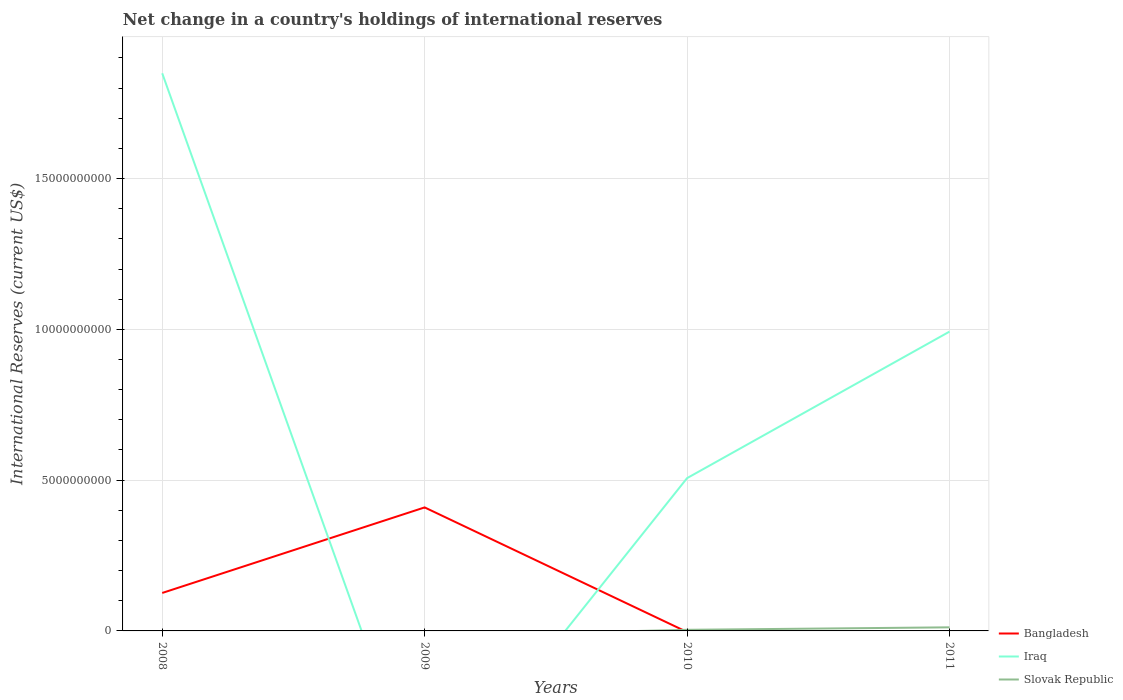How many different coloured lines are there?
Your answer should be very brief. 3. Does the line corresponding to Bangladesh intersect with the line corresponding to Iraq?
Provide a succinct answer. Yes. Is the number of lines equal to the number of legend labels?
Give a very brief answer. No. What is the total international reserves in Bangladesh in the graph?
Ensure brevity in your answer.  -2.84e+09. What is the difference between the highest and the second highest international reserves in Iraq?
Keep it short and to the point. 1.85e+1. Does the graph contain any zero values?
Your answer should be compact. Yes. Does the graph contain grids?
Offer a very short reply. Yes. What is the title of the graph?
Your response must be concise. Net change in a country's holdings of international reserves. Does "Arab World" appear as one of the legend labels in the graph?
Provide a succinct answer. No. What is the label or title of the X-axis?
Provide a succinct answer. Years. What is the label or title of the Y-axis?
Your answer should be compact. International Reserves (current US$). What is the International Reserves (current US$) in Bangladesh in 2008?
Provide a succinct answer. 1.26e+09. What is the International Reserves (current US$) in Iraq in 2008?
Provide a succinct answer. 1.85e+1. What is the International Reserves (current US$) of Slovak Republic in 2008?
Provide a short and direct response. 0. What is the International Reserves (current US$) in Bangladesh in 2009?
Keep it short and to the point. 4.10e+09. What is the International Reserves (current US$) of Iraq in 2009?
Provide a short and direct response. 0. What is the International Reserves (current US$) in Slovak Republic in 2009?
Your answer should be compact. 0. What is the International Reserves (current US$) of Iraq in 2010?
Keep it short and to the point. 5.07e+09. What is the International Reserves (current US$) in Slovak Republic in 2010?
Offer a very short reply. 3.67e+07. What is the International Reserves (current US$) of Iraq in 2011?
Keep it short and to the point. 9.92e+09. What is the International Reserves (current US$) in Slovak Republic in 2011?
Keep it short and to the point. 1.19e+08. Across all years, what is the maximum International Reserves (current US$) in Bangladesh?
Your answer should be compact. 4.10e+09. Across all years, what is the maximum International Reserves (current US$) of Iraq?
Ensure brevity in your answer.  1.85e+1. Across all years, what is the maximum International Reserves (current US$) of Slovak Republic?
Your response must be concise. 1.19e+08. Across all years, what is the minimum International Reserves (current US$) of Bangladesh?
Keep it short and to the point. 0. Across all years, what is the minimum International Reserves (current US$) of Iraq?
Keep it short and to the point. 0. What is the total International Reserves (current US$) in Bangladesh in the graph?
Offer a terse response. 5.35e+09. What is the total International Reserves (current US$) of Iraq in the graph?
Your answer should be compact. 3.35e+1. What is the total International Reserves (current US$) of Slovak Republic in the graph?
Your answer should be very brief. 1.56e+08. What is the difference between the International Reserves (current US$) of Bangladesh in 2008 and that in 2009?
Your answer should be compact. -2.84e+09. What is the difference between the International Reserves (current US$) in Iraq in 2008 and that in 2010?
Offer a very short reply. 1.34e+1. What is the difference between the International Reserves (current US$) in Iraq in 2008 and that in 2011?
Ensure brevity in your answer.  8.57e+09. What is the difference between the International Reserves (current US$) in Iraq in 2010 and that in 2011?
Ensure brevity in your answer.  -4.86e+09. What is the difference between the International Reserves (current US$) of Slovak Republic in 2010 and that in 2011?
Your answer should be compact. -8.25e+07. What is the difference between the International Reserves (current US$) in Bangladesh in 2008 and the International Reserves (current US$) in Iraq in 2010?
Your answer should be very brief. -3.81e+09. What is the difference between the International Reserves (current US$) in Bangladesh in 2008 and the International Reserves (current US$) in Slovak Republic in 2010?
Your answer should be compact. 1.22e+09. What is the difference between the International Reserves (current US$) in Iraq in 2008 and the International Reserves (current US$) in Slovak Republic in 2010?
Your response must be concise. 1.85e+1. What is the difference between the International Reserves (current US$) of Bangladesh in 2008 and the International Reserves (current US$) of Iraq in 2011?
Provide a succinct answer. -8.67e+09. What is the difference between the International Reserves (current US$) in Bangladesh in 2008 and the International Reserves (current US$) in Slovak Republic in 2011?
Provide a short and direct response. 1.14e+09. What is the difference between the International Reserves (current US$) of Iraq in 2008 and the International Reserves (current US$) of Slovak Republic in 2011?
Keep it short and to the point. 1.84e+1. What is the difference between the International Reserves (current US$) in Bangladesh in 2009 and the International Reserves (current US$) in Iraq in 2010?
Your response must be concise. -9.71e+08. What is the difference between the International Reserves (current US$) in Bangladesh in 2009 and the International Reserves (current US$) in Slovak Republic in 2010?
Give a very brief answer. 4.06e+09. What is the difference between the International Reserves (current US$) of Bangladesh in 2009 and the International Reserves (current US$) of Iraq in 2011?
Give a very brief answer. -5.83e+09. What is the difference between the International Reserves (current US$) of Bangladesh in 2009 and the International Reserves (current US$) of Slovak Republic in 2011?
Provide a succinct answer. 3.98e+09. What is the difference between the International Reserves (current US$) of Iraq in 2010 and the International Reserves (current US$) of Slovak Republic in 2011?
Your response must be concise. 4.95e+09. What is the average International Reserves (current US$) of Bangladesh per year?
Keep it short and to the point. 1.34e+09. What is the average International Reserves (current US$) in Iraq per year?
Your response must be concise. 8.37e+09. What is the average International Reserves (current US$) in Slovak Republic per year?
Give a very brief answer. 3.90e+07. In the year 2008, what is the difference between the International Reserves (current US$) in Bangladesh and International Reserves (current US$) in Iraq?
Your response must be concise. -1.72e+1. In the year 2010, what is the difference between the International Reserves (current US$) in Iraq and International Reserves (current US$) in Slovak Republic?
Give a very brief answer. 5.03e+09. In the year 2011, what is the difference between the International Reserves (current US$) of Iraq and International Reserves (current US$) of Slovak Republic?
Your response must be concise. 9.80e+09. What is the ratio of the International Reserves (current US$) in Bangladesh in 2008 to that in 2009?
Make the answer very short. 0.31. What is the ratio of the International Reserves (current US$) in Iraq in 2008 to that in 2010?
Make the answer very short. 3.65. What is the ratio of the International Reserves (current US$) of Iraq in 2008 to that in 2011?
Ensure brevity in your answer.  1.86. What is the ratio of the International Reserves (current US$) in Iraq in 2010 to that in 2011?
Provide a succinct answer. 0.51. What is the ratio of the International Reserves (current US$) of Slovak Republic in 2010 to that in 2011?
Your response must be concise. 0.31. What is the difference between the highest and the second highest International Reserves (current US$) in Iraq?
Offer a terse response. 8.57e+09. What is the difference between the highest and the lowest International Reserves (current US$) of Bangladesh?
Provide a succinct answer. 4.10e+09. What is the difference between the highest and the lowest International Reserves (current US$) of Iraq?
Your response must be concise. 1.85e+1. What is the difference between the highest and the lowest International Reserves (current US$) of Slovak Republic?
Your response must be concise. 1.19e+08. 